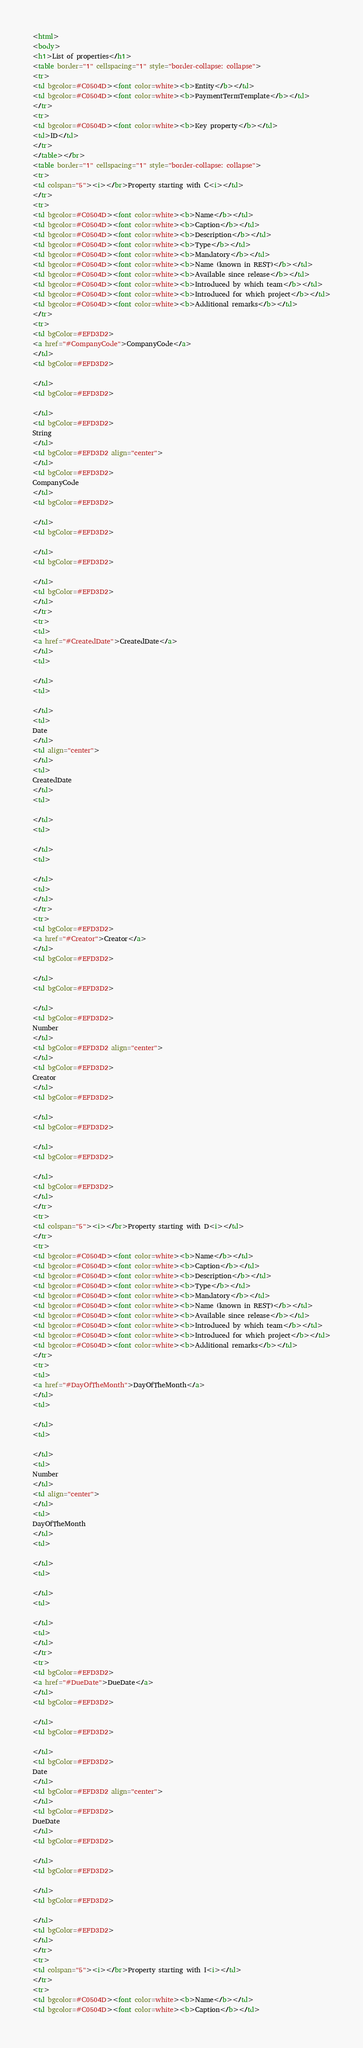Convert code to text. <code><loc_0><loc_0><loc_500><loc_500><_HTML_><html>
<body>
<h1>List of properties</h1>
<table border="1" cellspacing="1" style="border-collapse: collapse">
<tr>
<td bgcolor=#C0504D><font color=white><b>Entity</b></td>
<td bgcolor=#C0504D><font color=white><b>PaymentTermTemplate</b></td>
</tr>
<tr>
<td bgcolor=#C0504D><font color=white><b>Key property</b></td>
<td>ID</td>
</tr>
</table></br>
<table border="1" cellspacing="1" style="border-collapse: collapse">
<tr>
<td colspan="5"><i></br>Property starting with C<i></td>
</tr>
<tr>
<td bgcolor=#C0504D><font color=white><b>Name</b></td>
<td bgcolor=#C0504D><font color=white><b>Caption</b></td>
<td bgcolor=#C0504D><font color=white><b>Description</b></td>
<td bgcolor=#C0504D><font color=white><b>Type</b></td>
<td bgcolor=#C0504D><font color=white><b>Mandatory</b></td>
<td bgcolor=#C0504D><font color=white><b>Name (known in REST)</b></td>
<td bgcolor=#C0504D><font color=white><b>Available since release</b></td>
<td bgcolor=#C0504D><font color=white><b>Introduced by which team</b></td>
<td bgcolor=#C0504D><font color=white><b>Introduced for which project</b></td>
<td bgcolor=#C0504D><font color=white><b>Additional remarks</b></td>
</tr>
<tr>
<td bgColor=#EFD3D2>
<a href="#CompanyCode">CompanyCode</a>
</td>
<td bgColor=#EFD3D2>

</td>
<td bgColor=#EFD3D2>

</td>
<td bgColor=#EFD3D2>
String
</td>
<td bgColor=#EFD3D2 align="center">
</td>
<td bgColor=#EFD3D2>
CompanyCode
</td>
<td bgColor=#EFD3D2>

</td>
<td bgColor=#EFD3D2>

</td>
<td bgColor=#EFD3D2>

</td>
<td bgColor=#EFD3D2>
</td>
</tr>
<tr>
<td>
<a href="#CreatedDate">CreatedDate</a>
</td>
<td>

</td>
<td>

</td>
<td>
Date
</td>
<td align="center">
</td>
<td>
CreatedDate
</td>
<td>

</td>
<td>

</td>
<td>

</td>
<td>
</td>
</tr>
<tr>
<td bgColor=#EFD3D2>
<a href="#Creator">Creator</a>
</td>
<td bgColor=#EFD3D2>

</td>
<td bgColor=#EFD3D2>

</td>
<td bgColor=#EFD3D2>
Number
</td>
<td bgColor=#EFD3D2 align="center">
</td>
<td bgColor=#EFD3D2>
Creator
</td>
<td bgColor=#EFD3D2>

</td>
<td bgColor=#EFD3D2>

</td>
<td bgColor=#EFD3D2>

</td>
<td bgColor=#EFD3D2>
</td>
</tr>
<tr>
<td colspan="5"><i></br>Property starting with D<i></td>
</tr>
<tr>
<td bgcolor=#C0504D><font color=white><b>Name</b></td>
<td bgcolor=#C0504D><font color=white><b>Caption</b></td>
<td bgcolor=#C0504D><font color=white><b>Description</b></td>
<td bgcolor=#C0504D><font color=white><b>Type</b></td>
<td bgcolor=#C0504D><font color=white><b>Mandatory</b></td>
<td bgcolor=#C0504D><font color=white><b>Name (known in REST)</b></td>
<td bgcolor=#C0504D><font color=white><b>Available since release</b></td>
<td bgcolor=#C0504D><font color=white><b>Introduced by which team</b></td>
<td bgcolor=#C0504D><font color=white><b>Introduced for which project</b></td>
<td bgcolor=#C0504D><font color=white><b>Additional remarks</b></td>
</tr>
<tr>
<td>
<a href="#DayOfTheMonth">DayOfTheMonth</a>
</td>
<td>

</td>
<td>

</td>
<td>
Number
</td>
<td align="center">
</td>
<td>
DayOfTheMonth
</td>
<td>

</td>
<td>

</td>
<td>

</td>
<td>
</td>
</tr>
<tr>
<td bgColor=#EFD3D2>
<a href="#DueDate">DueDate</a>
</td>
<td bgColor=#EFD3D2>

</td>
<td bgColor=#EFD3D2>

</td>
<td bgColor=#EFD3D2>
Date
</td>
<td bgColor=#EFD3D2 align="center">
</td>
<td bgColor=#EFD3D2>
DueDate
</td>
<td bgColor=#EFD3D2>

</td>
<td bgColor=#EFD3D2>

</td>
<td bgColor=#EFD3D2>

</td>
<td bgColor=#EFD3D2>
</td>
</tr>
<tr>
<td colspan="5"><i></br>Property starting with I<i></td>
</tr>
<tr>
<td bgcolor=#C0504D><font color=white><b>Name</b></td>
<td bgcolor=#C0504D><font color=white><b>Caption</b></td></code> 